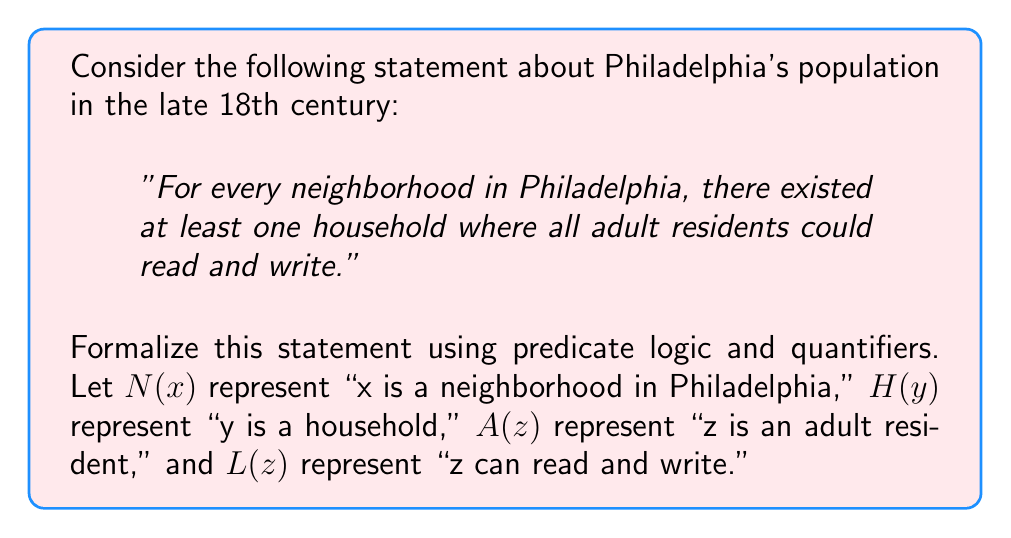Could you help me with this problem? To formalize this statement using predicate logic and quantifiers, we need to break it down into its components and translate each part:

1. "For every neighborhood in Philadelphia" can be represented by the universal quantifier $\forall x$.

2. "There existed at least one household" can be represented by the existential quantifier $\exists y$.

3. "Where all adult residents could read and write" requires another universal quantifier $\forall z$ and an implication.

Let's construct the statement step by step:

1. Start with the universal quantifier for neighborhoods:
   $\forall x (N(x) \rightarrow ...)$

2. Add the existential quantifier for households:
   $\forall x (N(x) \rightarrow \exists y (H(y) \land ...))$

3. Add the universal quantifier for adult residents and the implication for literacy:
   $\forall x (N(x) \rightarrow \exists y (H(y) \land \forall z ((A(z) \land \text{InHousehold}(z,y)) \rightarrow L(z))))$

4. We need to add a predicate to represent that an adult is in a specific household. Let's call this predicate $\text{InHousehold}(z,y)$, which means "z is in household y".

The final formalized statement in predicate logic is:

$$\forall x (N(x) \rightarrow \exists y (H(y) \land \forall z ((A(z) \land \text{InHousehold}(z,y)) \rightarrow L(z))))$$

This statement reads: "For all x, if x is a neighborhood in Philadelphia, then there exists a y such that y is a household, and for all z, if z is an adult resident and z is in household y, then z can read and write."
Answer: $$\forall x (N(x) \rightarrow \exists y (H(y) \land \forall z ((A(z) \land \text{InHousehold}(z,y)) \rightarrow L(z))))$$ 